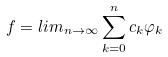<formula> <loc_0><loc_0><loc_500><loc_500>f = l i m _ { n \rightarrow \infty } \sum _ { k = 0 } ^ { n } c _ { k } \varphi _ { k }</formula> 